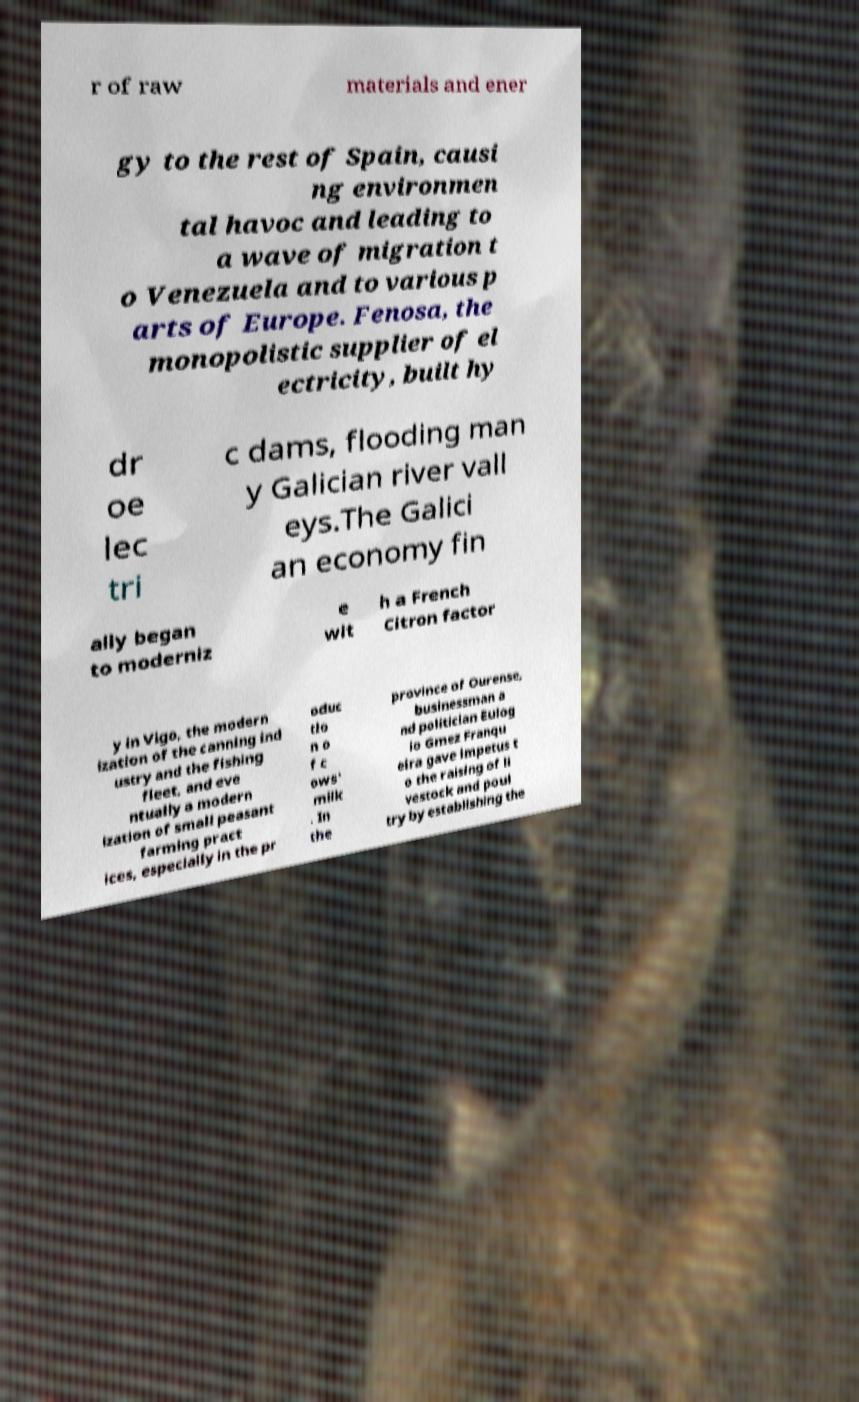For documentation purposes, I need the text within this image transcribed. Could you provide that? r of raw materials and ener gy to the rest of Spain, causi ng environmen tal havoc and leading to a wave of migration t o Venezuela and to various p arts of Europe. Fenosa, the monopolistic supplier of el ectricity, built hy dr oe lec tri c dams, flooding man y Galician river vall eys.The Galici an economy fin ally began to moderniz e wit h a French Citron factor y in Vigo, the modern ization of the canning ind ustry and the fishing fleet, and eve ntually a modern ization of small peasant farming pract ices, especially in the pr oduc tio n o f c ows' milk . In the province of Ourense, businessman a nd politician Eulog io Gmez Franqu eira gave impetus t o the raising of li vestock and poul try by establishing the 